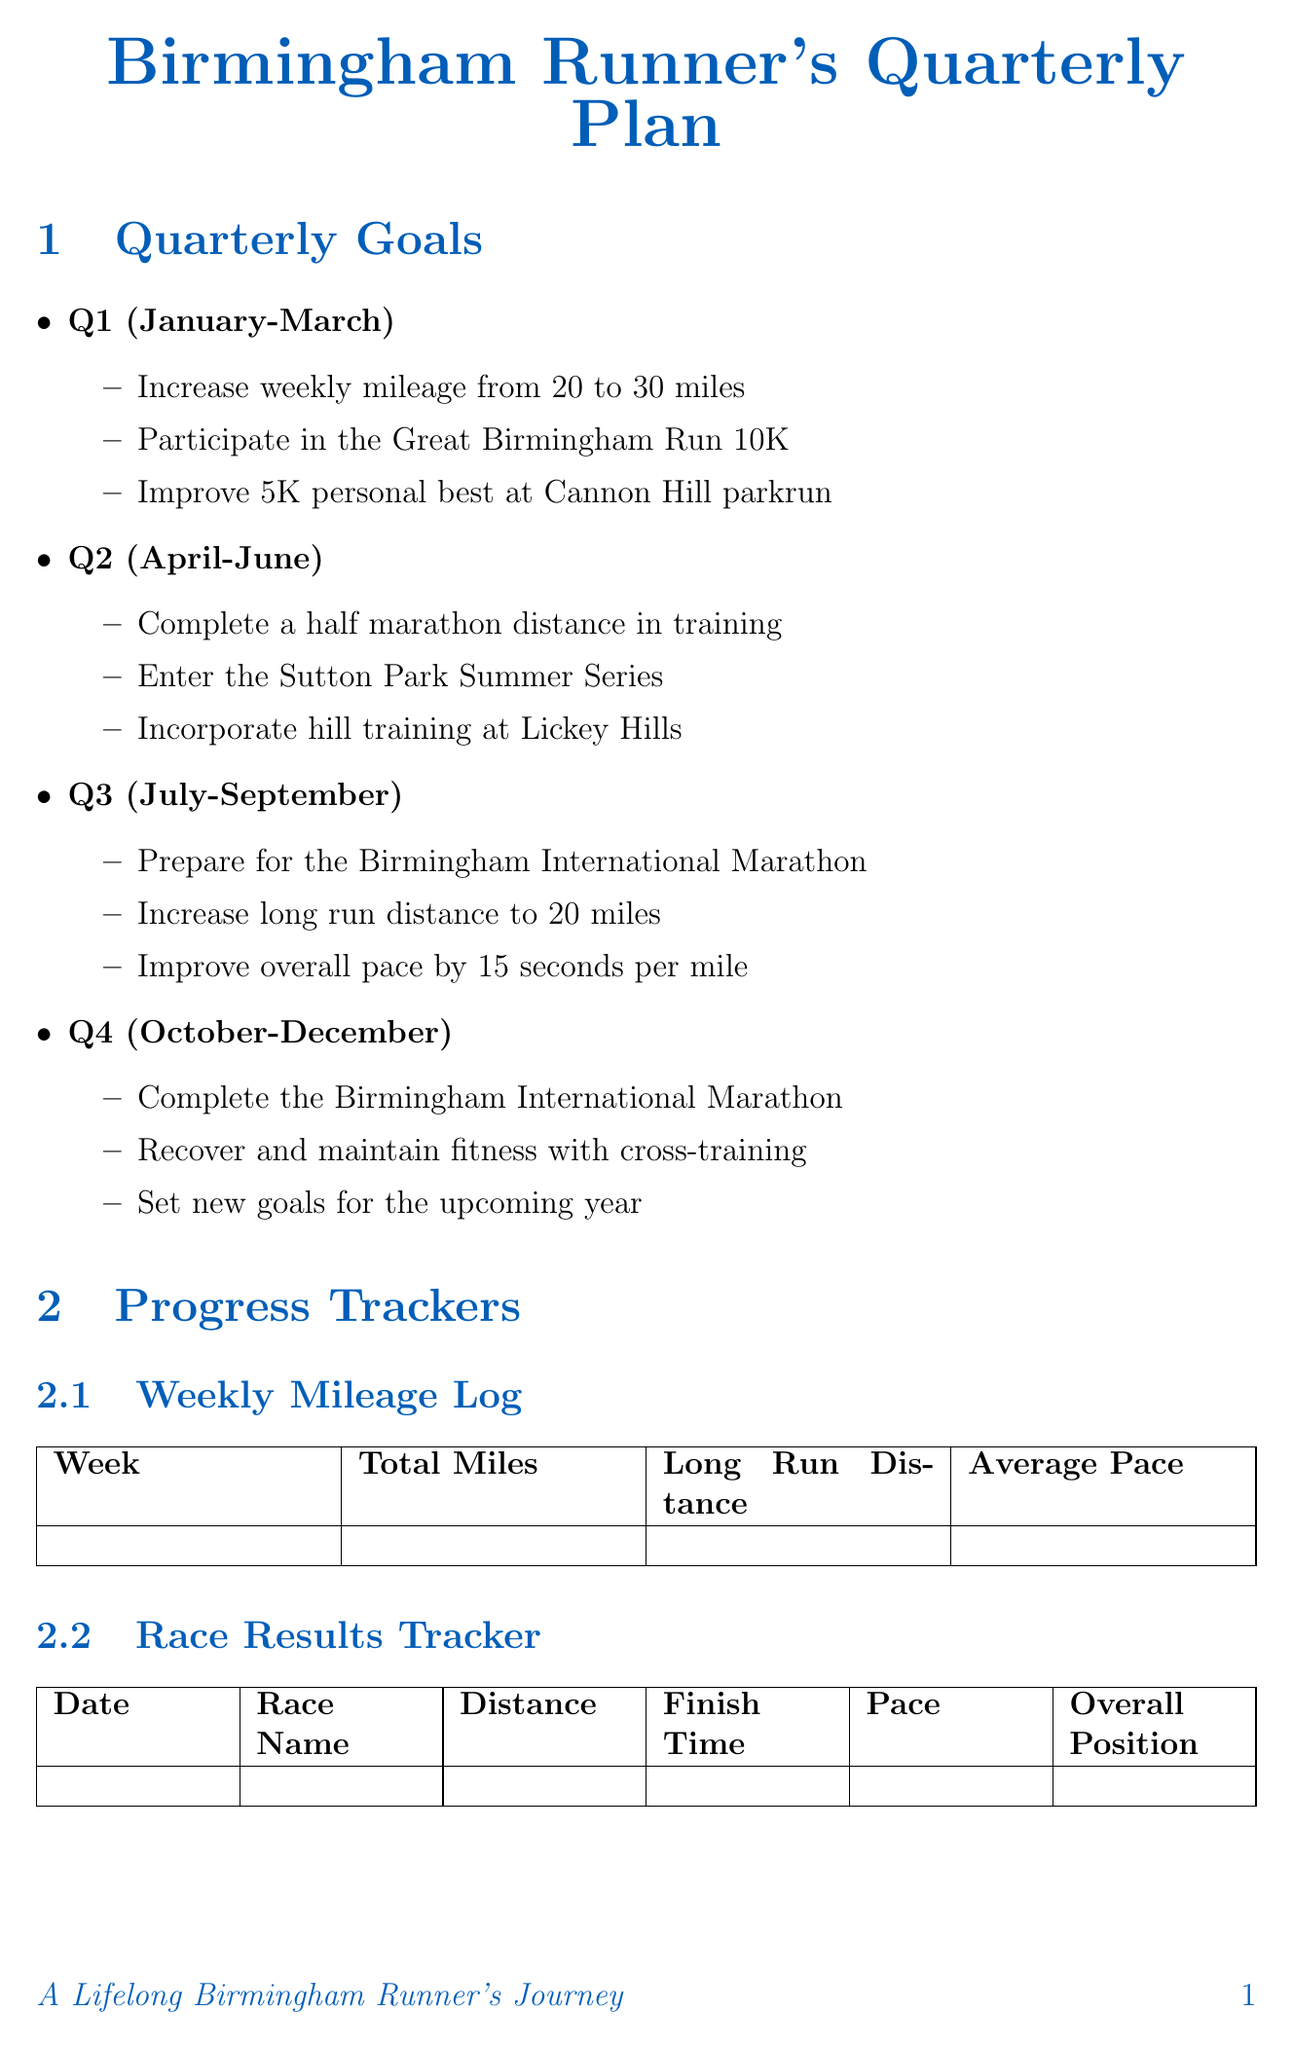What is the goal for Q1? The goal for Q1 is to increase weekly mileage from 20 to 30 miles, participate in the Great Birmingham Run 10K, and improve 5K personal best at Cannon Hill parkrun.
Answer: increase weekly mileage from 20 to 30 miles, participate in the Great Birmingham Run 10K, improve 5K personal best at Cannon Hill parkrun What is the distance of the Canal Loop? The distance of the Canal Loop route is listed as 5 miles in the document.
Answer: 5 miles What is the upcoming event date for the Birmingham International Marathon? The document states that the Birmingham International Marathon is scheduled for October 15, 2023.
Answer: October 15, 2023 How many goals are set for Q3? The document outlines three goals for Q3, including preparation for the Birmingham International Marathon, increasing long run distance, and improving overall pace.
Answer: 3 What is the primary focus during Q4? The focus during Q4 includes completing the Birmingham International Marathon, recovering and maintaining fitness, and setting new goals for the upcoming year.
Answer: completing the Birmingham International Marathon What should runners incorporate according to the training tips? The training tips suggest incorporating swimming sessions at Moseley Road Baths for low-impact cardio.
Answer: swimming sessions at Moseley Road Baths What is one of the metrics in the Weekly Mileage Log? One of the metrics listed for the Weekly Mileage Log is Total Miles.
Answer: Total Miles Which route is known for a mix of paved and trail surfaces? The route known for a mix of paved and trail surfaces is Edgbaston Reservoir.
Answer: Edgbaston Reservoir 